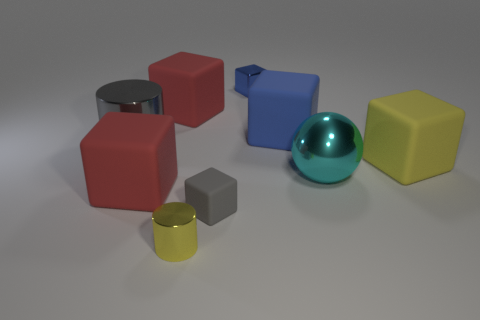Subtract all big matte cubes. How many cubes are left? 2 Subtract all yellow cylinders. How many cylinders are left? 1 Add 1 big yellow blocks. How many objects exist? 10 Subtract all cyan spheres. How many yellow blocks are left? 1 Subtract all cylinders. How many objects are left? 7 Subtract 1 cylinders. How many cylinders are left? 1 Subtract all blue blocks. Subtract all cyan balls. How many blocks are left? 4 Subtract all gray matte things. Subtract all metallic things. How many objects are left? 4 Add 1 yellow matte things. How many yellow matte things are left? 2 Add 9 metallic spheres. How many metallic spheres exist? 10 